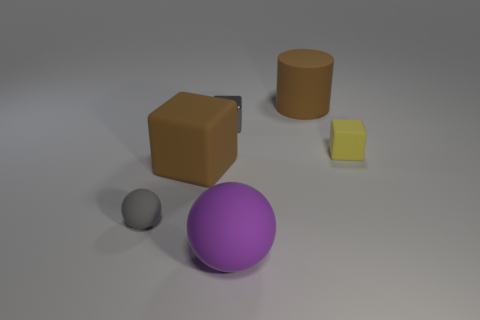Subtract all tiny cubes. How many cubes are left? 1 Add 1 small yellow cylinders. How many objects exist? 7 Subtract all cyan blocks. Subtract all red balls. How many blocks are left? 3 Subtract all cylinders. How many objects are left? 5 Subtract all tiny cyan things. Subtract all yellow rubber cubes. How many objects are left? 5 Add 4 small gray things. How many small gray things are left? 6 Add 6 tiny green rubber objects. How many tiny green rubber objects exist? 6 Subtract 0 yellow spheres. How many objects are left? 6 